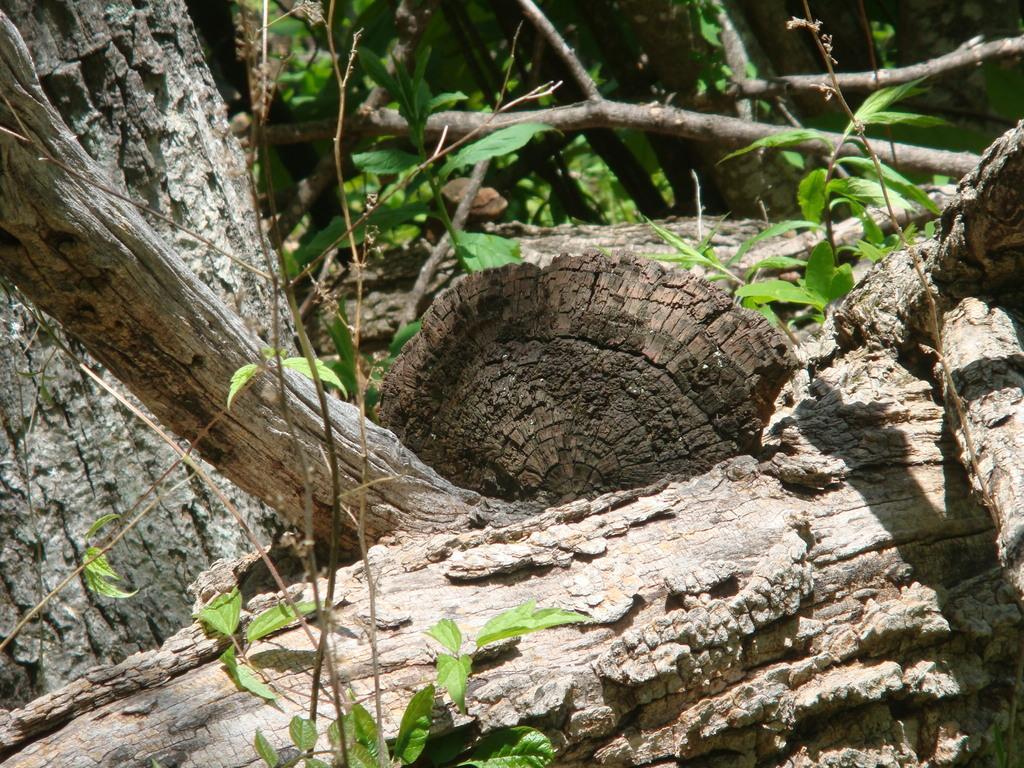In one or two sentences, can you explain what this image depicts? In this image in the foreground and background there are some trees and plants. 